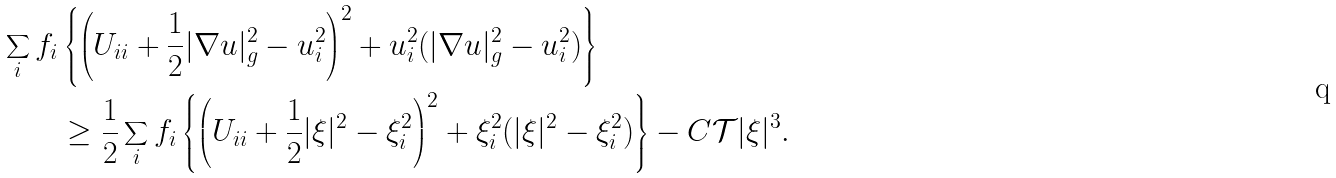Convert formula to latex. <formula><loc_0><loc_0><loc_500><loc_500>\sum _ { i } f _ { i } & \left \{ \left ( U _ { i i } + \frac { 1 } { 2 } | \nabla u | _ { g } ^ { 2 } - u _ { i } ^ { 2 } \right ) ^ { 2 } + u _ { i } ^ { 2 } ( | \nabla u | _ { g } ^ { 2 } - u _ { i } ^ { 2 } ) \right \} \\ & \geq \frac { 1 } { 2 } \sum _ { i } f _ { i } \left \{ \left ( U _ { i i } + \frac { 1 } { 2 } | \xi | ^ { 2 } - \xi _ { i } ^ { 2 } \right ) ^ { 2 } + \xi _ { i } ^ { 2 } ( | \xi | ^ { 2 } - \xi _ { i } ^ { 2 } ) \right \} - C { \mathcal { T } } | \xi | ^ { 3 } .</formula> 